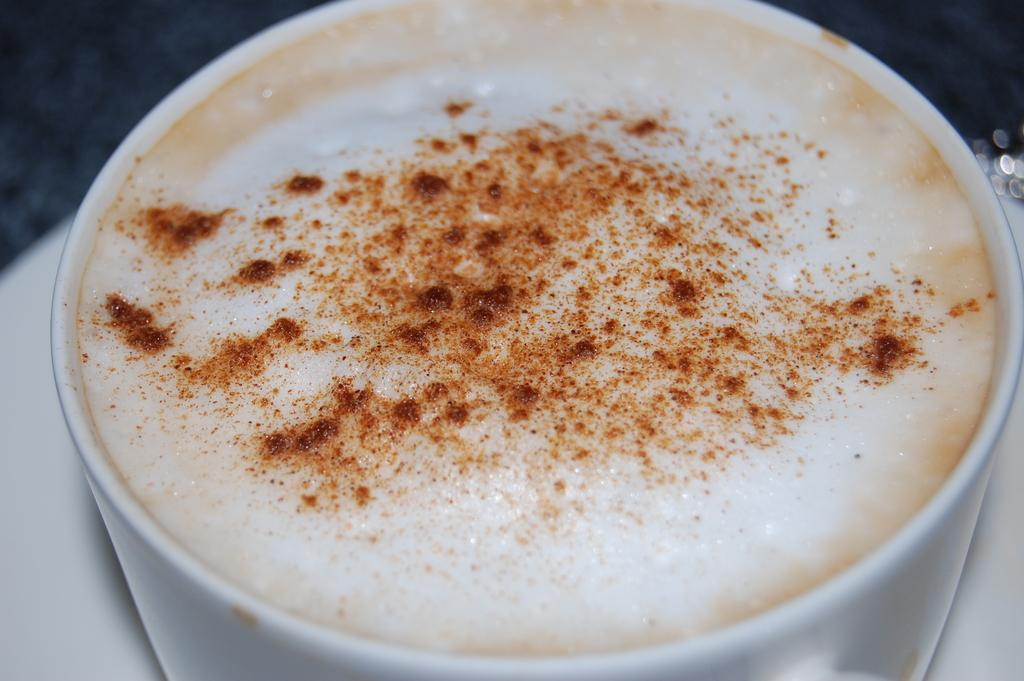What is in the cup that is visible in the image? There is a cup of hot beverage in the image. What is added to the hot beverage? Something is sprinkled on the hot beverage. What accompanies the cup in the image? There is a saucer in the image. What type of tin can be seen flying in the sky in the image? There is no tin or any object flying in the sky in the image. What kind of kite is being flown near the cup of hot beverage in the image? There is no kite present in the image. 